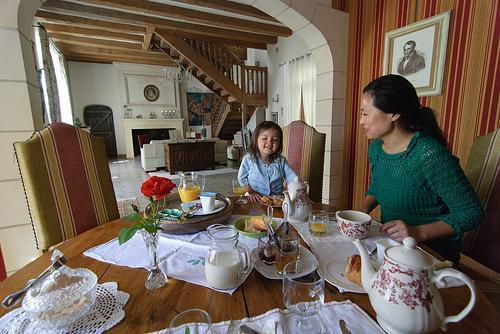How many people at the table?
Give a very brief answer. 2. How many flowers on the table?
Give a very brief answer. 1. 